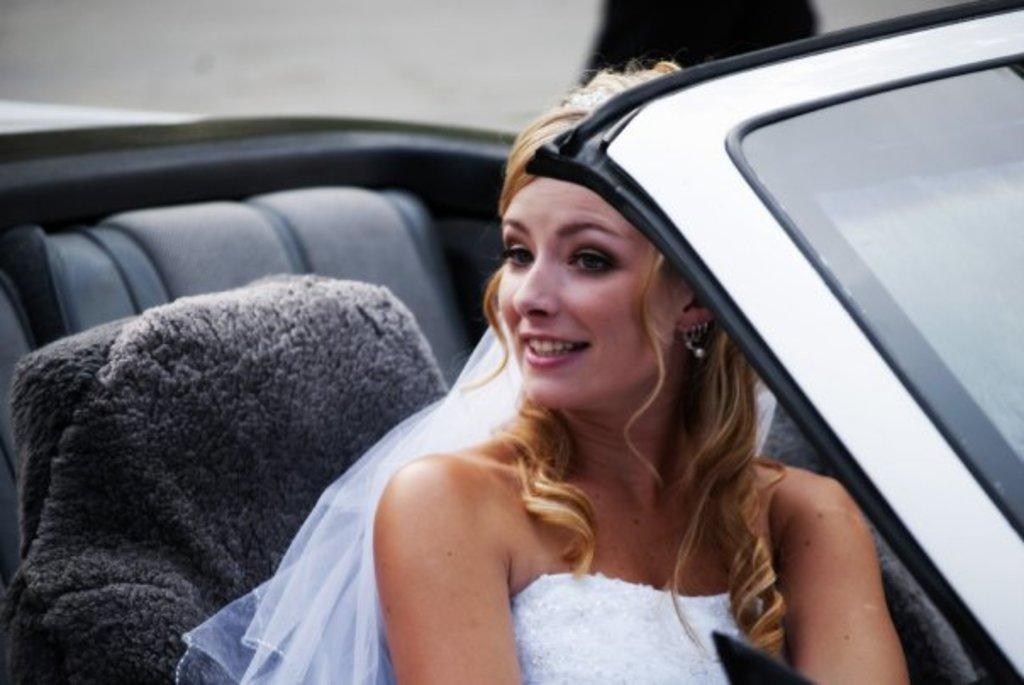Who is the main subject in the image? There is a woman in the image. What is the woman wearing? The woman is wearing a white dress. What is the woman doing in the image? The woman is seated in a car. What is the woman's facial expression in the image? The woman is smiling. What type of crown is the woman wearing in the image? There is no crown present in the image; the woman is wearing a white dress. Who is the owner of the car in the image? The facts provided do not indicate who the owner of the car is. 